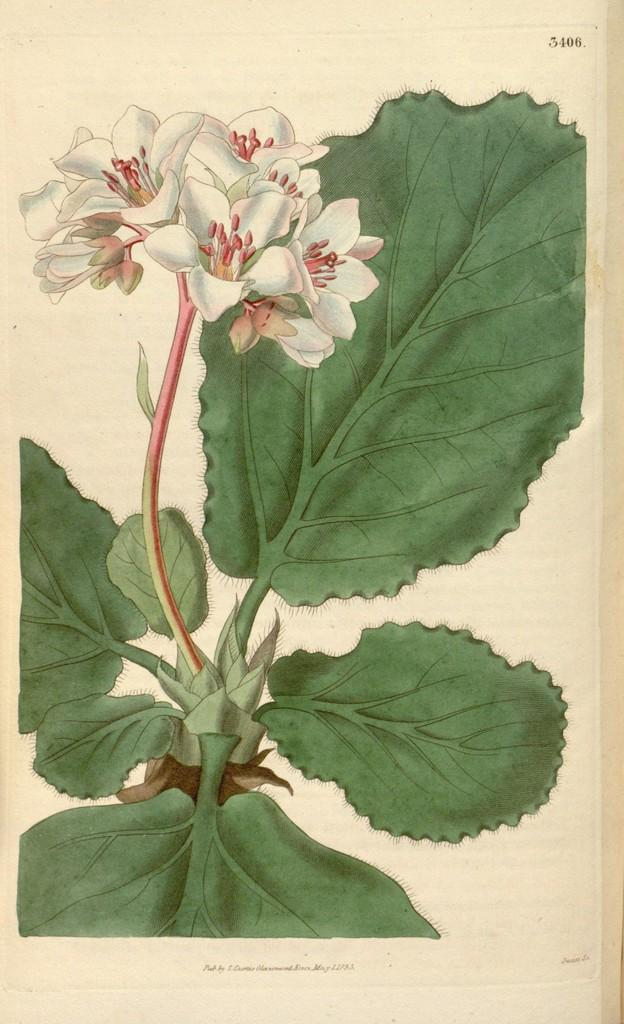What type of artwork is depicted in the image? The image is a painting. What type of plant is featured in the painting? There is a plant in the painting. What additional element can be seen in the painting? There is a flower in the painting. How many boats are visible in the painting? There are no boats present in the painting; it features a plant and a flower. What type of grain is growing near the flower in the painting? There is no grain present in the painting; it only features a plant and a flower. 